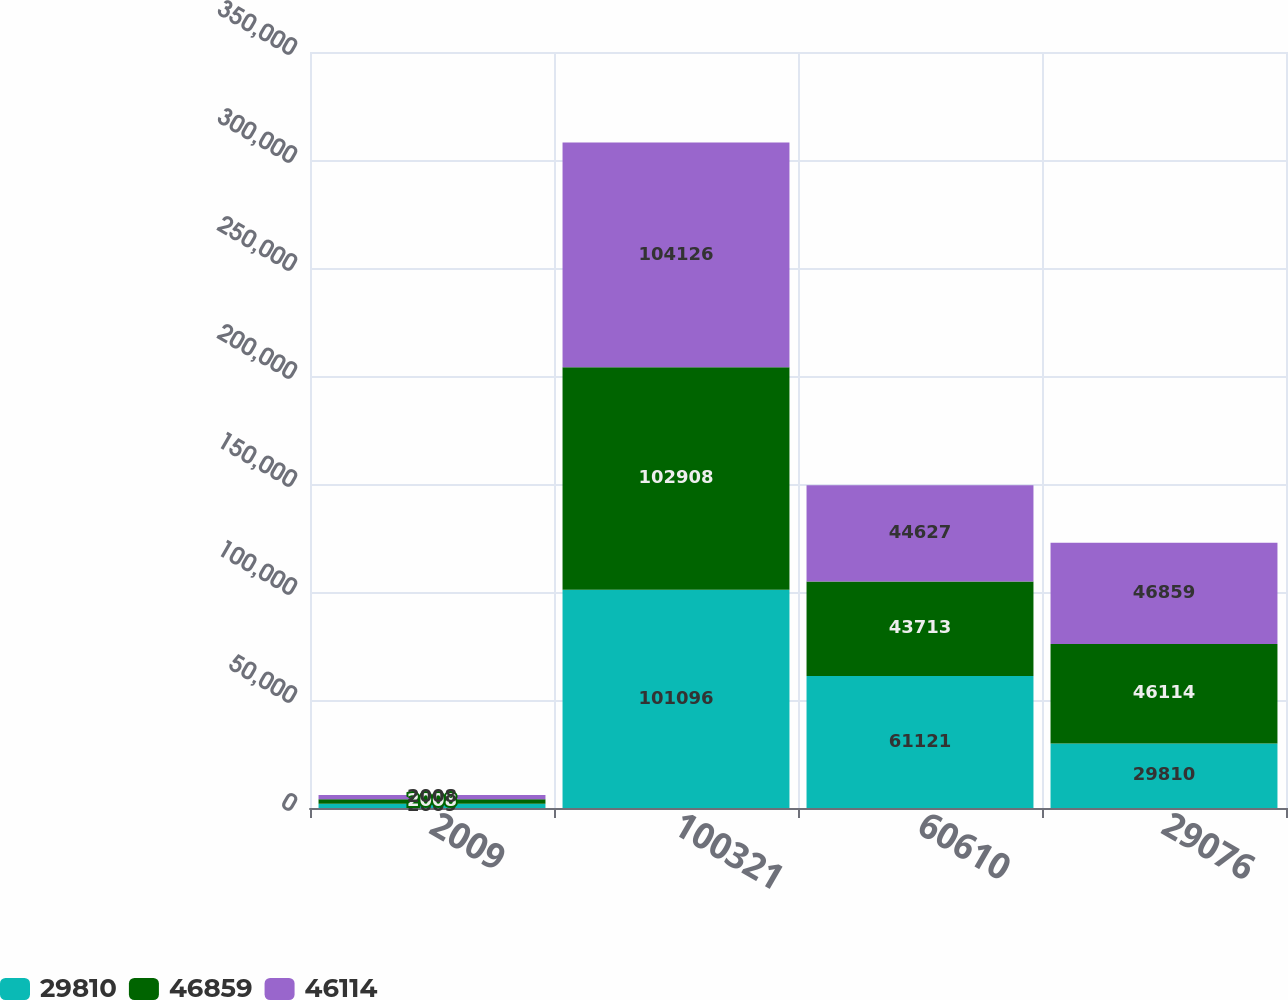Convert chart to OTSL. <chart><loc_0><loc_0><loc_500><loc_500><stacked_bar_chart><ecel><fcel>2009<fcel>100321<fcel>60610<fcel>29076<nl><fcel>29810<fcel>2009<fcel>101096<fcel>61121<fcel>29810<nl><fcel>46859<fcel>2008<fcel>102908<fcel>43713<fcel>46114<nl><fcel>46114<fcel>2008<fcel>104126<fcel>44627<fcel>46859<nl></chart> 